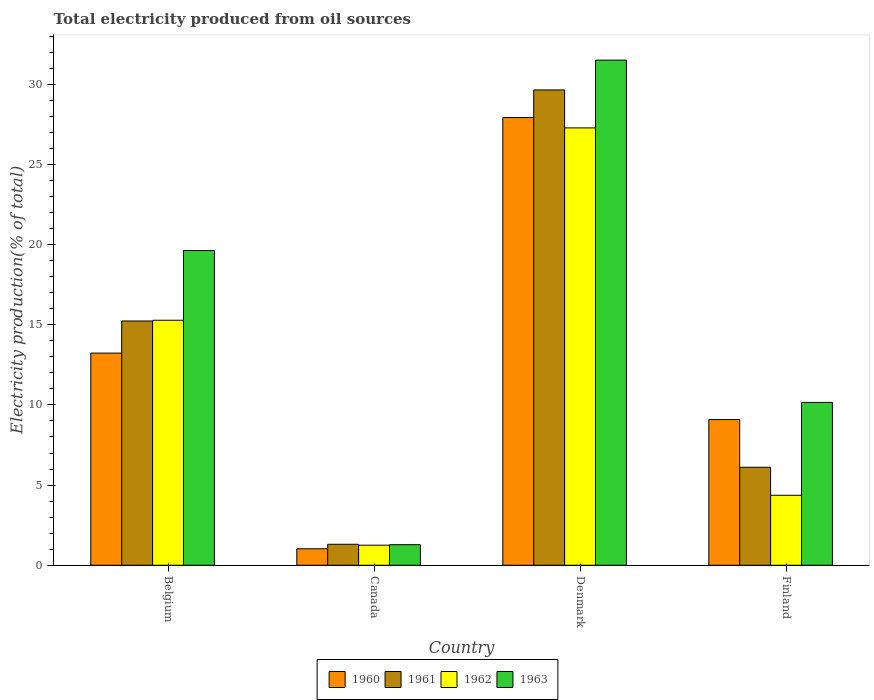How many different coloured bars are there?
Provide a succinct answer. 4. Are the number of bars per tick equal to the number of legend labels?
Provide a succinct answer. Yes. Are the number of bars on each tick of the X-axis equal?
Make the answer very short. Yes. How many bars are there on the 1st tick from the left?
Your response must be concise. 4. How many bars are there on the 4th tick from the right?
Your response must be concise. 4. What is the label of the 3rd group of bars from the left?
Ensure brevity in your answer.  Denmark. What is the total electricity produced in 1962 in Denmark?
Offer a very short reply. 27.28. Across all countries, what is the maximum total electricity produced in 1963?
Ensure brevity in your answer.  31.51. Across all countries, what is the minimum total electricity produced in 1962?
Offer a very short reply. 1.25. In which country was the total electricity produced in 1963 maximum?
Offer a very short reply. Denmark. What is the total total electricity produced in 1963 in the graph?
Your answer should be compact. 62.58. What is the difference between the total electricity produced in 1961 in Belgium and that in Denmark?
Make the answer very short. -14.41. What is the difference between the total electricity produced in 1960 in Belgium and the total electricity produced in 1962 in Canada?
Keep it short and to the point. 11.98. What is the average total electricity produced in 1961 per country?
Keep it short and to the point. 13.08. What is the difference between the total electricity produced of/in 1960 and total electricity produced of/in 1962 in Denmark?
Offer a terse response. 0.65. What is the ratio of the total electricity produced in 1961 in Belgium to that in Denmark?
Your response must be concise. 0.51. Is the total electricity produced in 1963 in Belgium less than that in Finland?
Your answer should be very brief. No. Is the difference between the total electricity produced in 1960 in Belgium and Canada greater than the difference between the total electricity produced in 1962 in Belgium and Canada?
Make the answer very short. No. What is the difference between the highest and the second highest total electricity produced in 1960?
Give a very brief answer. -18.84. What is the difference between the highest and the lowest total electricity produced in 1961?
Your answer should be very brief. 28.34. In how many countries, is the total electricity produced in 1960 greater than the average total electricity produced in 1960 taken over all countries?
Provide a short and direct response. 2. Is the sum of the total electricity produced in 1963 in Denmark and Finland greater than the maximum total electricity produced in 1962 across all countries?
Provide a succinct answer. Yes. Is it the case that in every country, the sum of the total electricity produced in 1961 and total electricity produced in 1963 is greater than the sum of total electricity produced in 1962 and total electricity produced in 1960?
Give a very brief answer. No. What does the 2nd bar from the right in Finland represents?
Give a very brief answer. 1962. Is it the case that in every country, the sum of the total electricity produced in 1963 and total electricity produced in 1962 is greater than the total electricity produced in 1961?
Give a very brief answer. Yes. How many countries are there in the graph?
Provide a succinct answer. 4. What is the difference between two consecutive major ticks on the Y-axis?
Provide a short and direct response. 5. Are the values on the major ticks of Y-axis written in scientific E-notation?
Your response must be concise. No. Does the graph contain any zero values?
Make the answer very short. No. Where does the legend appear in the graph?
Offer a terse response. Bottom center. How many legend labels are there?
Ensure brevity in your answer.  4. How are the legend labels stacked?
Make the answer very short. Horizontal. What is the title of the graph?
Ensure brevity in your answer.  Total electricity produced from oil sources. Does "1994" appear as one of the legend labels in the graph?
Make the answer very short. No. What is the label or title of the X-axis?
Offer a terse response. Country. What is the label or title of the Y-axis?
Your answer should be very brief. Electricity production(% of total). What is the Electricity production(% of total) in 1960 in Belgium?
Your answer should be compact. 13.23. What is the Electricity production(% of total) of 1961 in Belgium?
Your answer should be very brief. 15.23. What is the Electricity production(% of total) of 1962 in Belgium?
Your answer should be very brief. 15.28. What is the Electricity production(% of total) in 1963 in Belgium?
Provide a succinct answer. 19.63. What is the Electricity production(% of total) of 1960 in Canada?
Ensure brevity in your answer.  1.03. What is the Electricity production(% of total) in 1961 in Canada?
Your answer should be compact. 1.31. What is the Electricity production(% of total) of 1962 in Canada?
Your response must be concise. 1.25. What is the Electricity production(% of total) of 1963 in Canada?
Provide a short and direct response. 1.28. What is the Electricity production(% of total) in 1960 in Denmark?
Provide a short and direct response. 27.92. What is the Electricity production(% of total) of 1961 in Denmark?
Ensure brevity in your answer.  29.65. What is the Electricity production(% of total) in 1962 in Denmark?
Your answer should be compact. 27.28. What is the Electricity production(% of total) in 1963 in Denmark?
Keep it short and to the point. 31.51. What is the Electricity production(% of total) in 1960 in Finland?
Provide a short and direct response. 9.09. What is the Electricity production(% of total) in 1961 in Finland?
Your answer should be compact. 6.11. What is the Electricity production(% of total) in 1962 in Finland?
Offer a terse response. 4.36. What is the Electricity production(% of total) of 1963 in Finland?
Your answer should be very brief. 10.16. Across all countries, what is the maximum Electricity production(% of total) in 1960?
Your answer should be very brief. 27.92. Across all countries, what is the maximum Electricity production(% of total) of 1961?
Give a very brief answer. 29.65. Across all countries, what is the maximum Electricity production(% of total) in 1962?
Offer a very short reply. 27.28. Across all countries, what is the maximum Electricity production(% of total) in 1963?
Provide a short and direct response. 31.51. Across all countries, what is the minimum Electricity production(% of total) in 1960?
Offer a very short reply. 1.03. Across all countries, what is the minimum Electricity production(% of total) in 1961?
Provide a succinct answer. 1.31. Across all countries, what is the minimum Electricity production(% of total) of 1962?
Provide a succinct answer. 1.25. Across all countries, what is the minimum Electricity production(% of total) of 1963?
Provide a short and direct response. 1.28. What is the total Electricity production(% of total) in 1960 in the graph?
Give a very brief answer. 51.27. What is the total Electricity production(% of total) of 1961 in the graph?
Ensure brevity in your answer.  52.3. What is the total Electricity production(% of total) of 1962 in the graph?
Your answer should be compact. 48.18. What is the total Electricity production(% of total) in 1963 in the graph?
Your response must be concise. 62.58. What is the difference between the Electricity production(% of total) of 1960 in Belgium and that in Canada?
Provide a short and direct response. 12.2. What is the difference between the Electricity production(% of total) of 1961 in Belgium and that in Canada?
Ensure brevity in your answer.  13.93. What is the difference between the Electricity production(% of total) in 1962 in Belgium and that in Canada?
Keep it short and to the point. 14.03. What is the difference between the Electricity production(% of total) of 1963 in Belgium and that in Canada?
Offer a very short reply. 18.35. What is the difference between the Electricity production(% of total) in 1960 in Belgium and that in Denmark?
Keep it short and to the point. -14.69. What is the difference between the Electricity production(% of total) of 1961 in Belgium and that in Denmark?
Give a very brief answer. -14.41. What is the difference between the Electricity production(% of total) in 1962 in Belgium and that in Denmark?
Your answer should be compact. -12. What is the difference between the Electricity production(% of total) of 1963 in Belgium and that in Denmark?
Offer a very short reply. -11.87. What is the difference between the Electricity production(% of total) of 1960 in Belgium and that in Finland?
Provide a succinct answer. 4.14. What is the difference between the Electricity production(% of total) in 1961 in Belgium and that in Finland?
Provide a short and direct response. 9.12. What is the difference between the Electricity production(% of total) of 1962 in Belgium and that in Finland?
Your answer should be compact. 10.92. What is the difference between the Electricity production(% of total) of 1963 in Belgium and that in Finland?
Your answer should be very brief. 9.47. What is the difference between the Electricity production(% of total) in 1960 in Canada and that in Denmark?
Your answer should be very brief. -26.9. What is the difference between the Electricity production(% of total) of 1961 in Canada and that in Denmark?
Ensure brevity in your answer.  -28.34. What is the difference between the Electricity production(% of total) of 1962 in Canada and that in Denmark?
Your answer should be compact. -26.03. What is the difference between the Electricity production(% of total) in 1963 in Canada and that in Denmark?
Offer a very short reply. -30.22. What is the difference between the Electricity production(% of total) of 1960 in Canada and that in Finland?
Offer a terse response. -8.06. What is the difference between the Electricity production(% of total) in 1961 in Canada and that in Finland?
Provide a succinct answer. -4.8. What is the difference between the Electricity production(% of total) in 1962 in Canada and that in Finland?
Your response must be concise. -3.11. What is the difference between the Electricity production(% of total) of 1963 in Canada and that in Finland?
Provide a succinct answer. -8.87. What is the difference between the Electricity production(% of total) of 1960 in Denmark and that in Finland?
Offer a very short reply. 18.84. What is the difference between the Electricity production(% of total) of 1961 in Denmark and that in Finland?
Ensure brevity in your answer.  23.53. What is the difference between the Electricity production(% of total) in 1962 in Denmark and that in Finland?
Provide a succinct answer. 22.91. What is the difference between the Electricity production(% of total) in 1963 in Denmark and that in Finland?
Offer a terse response. 21.35. What is the difference between the Electricity production(% of total) in 1960 in Belgium and the Electricity production(% of total) in 1961 in Canada?
Your answer should be very brief. 11.92. What is the difference between the Electricity production(% of total) of 1960 in Belgium and the Electricity production(% of total) of 1962 in Canada?
Offer a terse response. 11.98. What is the difference between the Electricity production(% of total) in 1960 in Belgium and the Electricity production(% of total) in 1963 in Canada?
Provide a succinct answer. 11.95. What is the difference between the Electricity production(% of total) of 1961 in Belgium and the Electricity production(% of total) of 1962 in Canada?
Your answer should be compact. 13.98. What is the difference between the Electricity production(% of total) in 1961 in Belgium and the Electricity production(% of total) in 1963 in Canada?
Make the answer very short. 13.95. What is the difference between the Electricity production(% of total) in 1962 in Belgium and the Electricity production(% of total) in 1963 in Canada?
Your answer should be compact. 14. What is the difference between the Electricity production(% of total) of 1960 in Belgium and the Electricity production(% of total) of 1961 in Denmark?
Provide a succinct answer. -16.41. What is the difference between the Electricity production(% of total) of 1960 in Belgium and the Electricity production(% of total) of 1962 in Denmark?
Offer a very short reply. -14.05. What is the difference between the Electricity production(% of total) of 1960 in Belgium and the Electricity production(% of total) of 1963 in Denmark?
Provide a succinct answer. -18.27. What is the difference between the Electricity production(% of total) in 1961 in Belgium and the Electricity production(% of total) in 1962 in Denmark?
Your response must be concise. -12.04. What is the difference between the Electricity production(% of total) of 1961 in Belgium and the Electricity production(% of total) of 1963 in Denmark?
Provide a short and direct response. -16.27. What is the difference between the Electricity production(% of total) of 1962 in Belgium and the Electricity production(% of total) of 1963 in Denmark?
Your answer should be compact. -16.22. What is the difference between the Electricity production(% of total) in 1960 in Belgium and the Electricity production(% of total) in 1961 in Finland?
Your answer should be compact. 7.12. What is the difference between the Electricity production(% of total) in 1960 in Belgium and the Electricity production(% of total) in 1962 in Finland?
Ensure brevity in your answer.  8.87. What is the difference between the Electricity production(% of total) in 1960 in Belgium and the Electricity production(% of total) in 1963 in Finland?
Ensure brevity in your answer.  3.08. What is the difference between the Electricity production(% of total) of 1961 in Belgium and the Electricity production(% of total) of 1962 in Finland?
Your response must be concise. 10.87. What is the difference between the Electricity production(% of total) of 1961 in Belgium and the Electricity production(% of total) of 1963 in Finland?
Offer a terse response. 5.08. What is the difference between the Electricity production(% of total) of 1962 in Belgium and the Electricity production(% of total) of 1963 in Finland?
Your answer should be compact. 5.12. What is the difference between the Electricity production(% of total) in 1960 in Canada and the Electricity production(% of total) in 1961 in Denmark?
Make the answer very short. -28.62. What is the difference between the Electricity production(% of total) of 1960 in Canada and the Electricity production(% of total) of 1962 in Denmark?
Provide a short and direct response. -26.25. What is the difference between the Electricity production(% of total) of 1960 in Canada and the Electricity production(% of total) of 1963 in Denmark?
Keep it short and to the point. -30.48. What is the difference between the Electricity production(% of total) of 1961 in Canada and the Electricity production(% of total) of 1962 in Denmark?
Your answer should be compact. -25.97. What is the difference between the Electricity production(% of total) in 1961 in Canada and the Electricity production(% of total) in 1963 in Denmark?
Provide a succinct answer. -30.2. What is the difference between the Electricity production(% of total) in 1962 in Canada and the Electricity production(% of total) in 1963 in Denmark?
Your answer should be very brief. -30.25. What is the difference between the Electricity production(% of total) in 1960 in Canada and the Electricity production(% of total) in 1961 in Finland?
Provide a short and direct response. -5.08. What is the difference between the Electricity production(% of total) of 1960 in Canada and the Electricity production(% of total) of 1962 in Finland?
Your answer should be very brief. -3.34. What is the difference between the Electricity production(% of total) of 1960 in Canada and the Electricity production(% of total) of 1963 in Finland?
Your answer should be compact. -9.13. What is the difference between the Electricity production(% of total) in 1961 in Canada and the Electricity production(% of total) in 1962 in Finland?
Offer a terse response. -3.06. What is the difference between the Electricity production(% of total) of 1961 in Canada and the Electricity production(% of total) of 1963 in Finland?
Ensure brevity in your answer.  -8.85. What is the difference between the Electricity production(% of total) in 1962 in Canada and the Electricity production(% of total) in 1963 in Finland?
Offer a terse response. -8.91. What is the difference between the Electricity production(% of total) in 1960 in Denmark and the Electricity production(% of total) in 1961 in Finland?
Offer a very short reply. 21.81. What is the difference between the Electricity production(% of total) of 1960 in Denmark and the Electricity production(% of total) of 1962 in Finland?
Your answer should be very brief. 23.56. What is the difference between the Electricity production(% of total) in 1960 in Denmark and the Electricity production(% of total) in 1963 in Finland?
Provide a succinct answer. 17.77. What is the difference between the Electricity production(% of total) of 1961 in Denmark and the Electricity production(% of total) of 1962 in Finland?
Provide a succinct answer. 25.28. What is the difference between the Electricity production(% of total) in 1961 in Denmark and the Electricity production(% of total) in 1963 in Finland?
Provide a short and direct response. 19.49. What is the difference between the Electricity production(% of total) of 1962 in Denmark and the Electricity production(% of total) of 1963 in Finland?
Provide a short and direct response. 17.12. What is the average Electricity production(% of total) of 1960 per country?
Ensure brevity in your answer.  12.82. What is the average Electricity production(% of total) of 1961 per country?
Provide a succinct answer. 13.08. What is the average Electricity production(% of total) in 1962 per country?
Provide a succinct answer. 12.04. What is the average Electricity production(% of total) of 1963 per country?
Give a very brief answer. 15.64. What is the difference between the Electricity production(% of total) of 1960 and Electricity production(% of total) of 1961 in Belgium?
Your answer should be very brief. -2. What is the difference between the Electricity production(% of total) in 1960 and Electricity production(% of total) in 1962 in Belgium?
Keep it short and to the point. -2.05. What is the difference between the Electricity production(% of total) in 1960 and Electricity production(% of total) in 1963 in Belgium?
Give a very brief answer. -6.4. What is the difference between the Electricity production(% of total) of 1961 and Electricity production(% of total) of 1962 in Belgium?
Your response must be concise. -0.05. What is the difference between the Electricity production(% of total) in 1961 and Electricity production(% of total) in 1963 in Belgium?
Offer a very short reply. -4.4. What is the difference between the Electricity production(% of total) of 1962 and Electricity production(% of total) of 1963 in Belgium?
Your answer should be very brief. -4.35. What is the difference between the Electricity production(% of total) in 1960 and Electricity production(% of total) in 1961 in Canada?
Ensure brevity in your answer.  -0.28. What is the difference between the Electricity production(% of total) of 1960 and Electricity production(% of total) of 1962 in Canada?
Ensure brevity in your answer.  -0.22. What is the difference between the Electricity production(% of total) of 1960 and Electricity production(% of total) of 1963 in Canada?
Keep it short and to the point. -0.26. What is the difference between the Electricity production(% of total) in 1961 and Electricity production(% of total) in 1962 in Canada?
Offer a very short reply. 0.06. What is the difference between the Electricity production(% of total) of 1961 and Electricity production(% of total) of 1963 in Canada?
Provide a short and direct response. 0.03. What is the difference between the Electricity production(% of total) in 1962 and Electricity production(% of total) in 1963 in Canada?
Offer a terse response. -0.03. What is the difference between the Electricity production(% of total) in 1960 and Electricity production(% of total) in 1961 in Denmark?
Ensure brevity in your answer.  -1.72. What is the difference between the Electricity production(% of total) in 1960 and Electricity production(% of total) in 1962 in Denmark?
Offer a terse response. 0.65. What is the difference between the Electricity production(% of total) of 1960 and Electricity production(% of total) of 1963 in Denmark?
Provide a succinct answer. -3.58. What is the difference between the Electricity production(% of total) of 1961 and Electricity production(% of total) of 1962 in Denmark?
Ensure brevity in your answer.  2.37. What is the difference between the Electricity production(% of total) of 1961 and Electricity production(% of total) of 1963 in Denmark?
Provide a short and direct response. -1.86. What is the difference between the Electricity production(% of total) in 1962 and Electricity production(% of total) in 1963 in Denmark?
Make the answer very short. -4.23. What is the difference between the Electricity production(% of total) of 1960 and Electricity production(% of total) of 1961 in Finland?
Offer a very short reply. 2.98. What is the difference between the Electricity production(% of total) in 1960 and Electricity production(% of total) in 1962 in Finland?
Your response must be concise. 4.72. What is the difference between the Electricity production(% of total) in 1960 and Electricity production(% of total) in 1963 in Finland?
Make the answer very short. -1.07. What is the difference between the Electricity production(% of total) of 1961 and Electricity production(% of total) of 1962 in Finland?
Your answer should be very brief. 1.75. What is the difference between the Electricity production(% of total) of 1961 and Electricity production(% of total) of 1963 in Finland?
Your answer should be very brief. -4.04. What is the difference between the Electricity production(% of total) in 1962 and Electricity production(% of total) in 1963 in Finland?
Offer a terse response. -5.79. What is the ratio of the Electricity production(% of total) of 1960 in Belgium to that in Canada?
Your response must be concise. 12.86. What is the ratio of the Electricity production(% of total) in 1961 in Belgium to that in Canada?
Provide a succinct answer. 11.64. What is the ratio of the Electricity production(% of total) in 1962 in Belgium to that in Canada?
Keep it short and to the point. 12.21. What is the ratio of the Electricity production(% of total) in 1963 in Belgium to that in Canada?
Make the answer very short. 15.29. What is the ratio of the Electricity production(% of total) of 1960 in Belgium to that in Denmark?
Offer a terse response. 0.47. What is the ratio of the Electricity production(% of total) in 1961 in Belgium to that in Denmark?
Provide a succinct answer. 0.51. What is the ratio of the Electricity production(% of total) of 1962 in Belgium to that in Denmark?
Offer a very short reply. 0.56. What is the ratio of the Electricity production(% of total) in 1963 in Belgium to that in Denmark?
Your response must be concise. 0.62. What is the ratio of the Electricity production(% of total) in 1960 in Belgium to that in Finland?
Keep it short and to the point. 1.46. What is the ratio of the Electricity production(% of total) in 1961 in Belgium to that in Finland?
Provide a succinct answer. 2.49. What is the ratio of the Electricity production(% of total) of 1962 in Belgium to that in Finland?
Your answer should be very brief. 3.5. What is the ratio of the Electricity production(% of total) in 1963 in Belgium to that in Finland?
Keep it short and to the point. 1.93. What is the ratio of the Electricity production(% of total) in 1960 in Canada to that in Denmark?
Offer a very short reply. 0.04. What is the ratio of the Electricity production(% of total) of 1961 in Canada to that in Denmark?
Offer a terse response. 0.04. What is the ratio of the Electricity production(% of total) in 1962 in Canada to that in Denmark?
Offer a very short reply. 0.05. What is the ratio of the Electricity production(% of total) in 1963 in Canada to that in Denmark?
Offer a very short reply. 0.04. What is the ratio of the Electricity production(% of total) in 1960 in Canada to that in Finland?
Offer a terse response. 0.11. What is the ratio of the Electricity production(% of total) in 1961 in Canada to that in Finland?
Your response must be concise. 0.21. What is the ratio of the Electricity production(% of total) in 1962 in Canada to that in Finland?
Give a very brief answer. 0.29. What is the ratio of the Electricity production(% of total) in 1963 in Canada to that in Finland?
Ensure brevity in your answer.  0.13. What is the ratio of the Electricity production(% of total) in 1960 in Denmark to that in Finland?
Provide a short and direct response. 3.07. What is the ratio of the Electricity production(% of total) of 1961 in Denmark to that in Finland?
Make the answer very short. 4.85. What is the ratio of the Electricity production(% of total) in 1962 in Denmark to that in Finland?
Give a very brief answer. 6.25. What is the ratio of the Electricity production(% of total) in 1963 in Denmark to that in Finland?
Offer a very short reply. 3.1. What is the difference between the highest and the second highest Electricity production(% of total) of 1960?
Keep it short and to the point. 14.69. What is the difference between the highest and the second highest Electricity production(% of total) of 1961?
Your answer should be compact. 14.41. What is the difference between the highest and the second highest Electricity production(% of total) in 1962?
Provide a succinct answer. 12. What is the difference between the highest and the second highest Electricity production(% of total) in 1963?
Provide a short and direct response. 11.87. What is the difference between the highest and the lowest Electricity production(% of total) of 1960?
Provide a succinct answer. 26.9. What is the difference between the highest and the lowest Electricity production(% of total) of 1961?
Keep it short and to the point. 28.34. What is the difference between the highest and the lowest Electricity production(% of total) in 1962?
Offer a terse response. 26.03. What is the difference between the highest and the lowest Electricity production(% of total) in 1963?
Offer a very short reply. 30.22. 